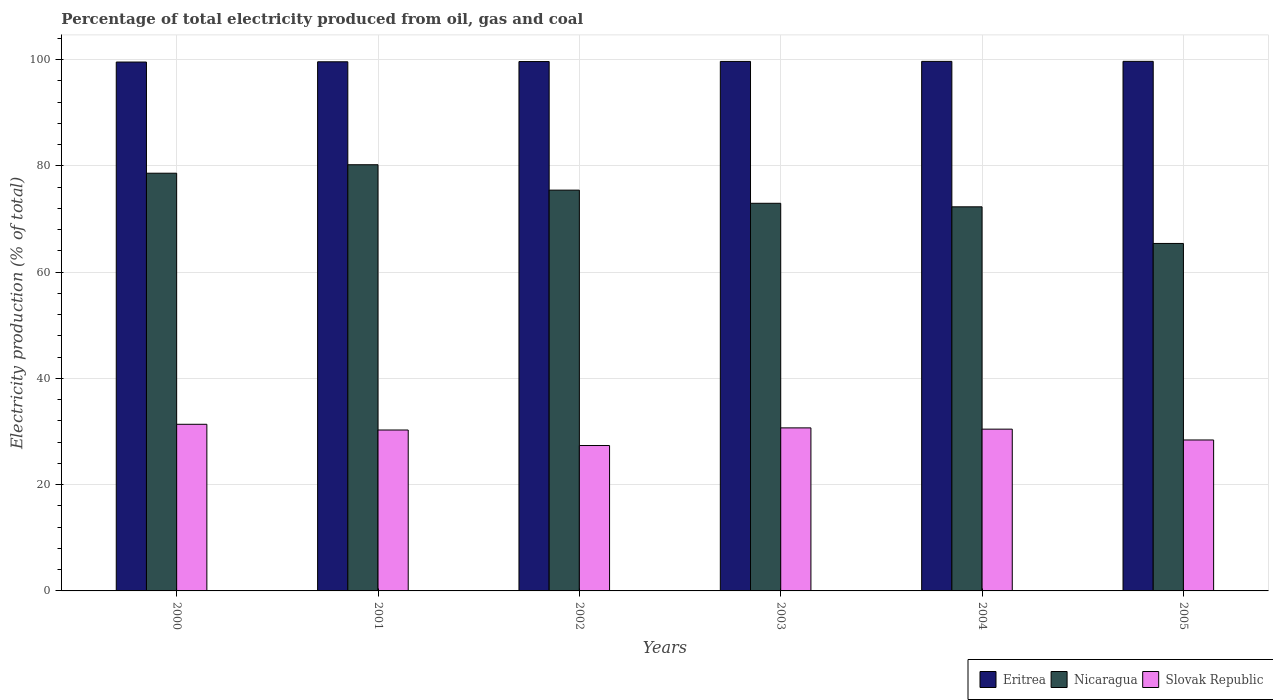How many different coloured bars are there?
Give a very brief answer. 3. How many groups of bars are there?
Offer a very short reply. 6. What is the label of the 5th group of bars from the left?
Give a very brief answer. 2004. In how many cases, is the number of bars for a given year not equal to the number of legend labels?
Give a very brief answer. 0. What is the electricity production in in Slovak Republic in 2003?
Your answer should be compact. 30.68. Across all years, what is the maximum electricity production in in Eritrea?
Offer a terse response. 99.65. Across all years, what is the minimum electricity production in in Eritrea?
Your answer should be very brief. 99.52. In which year was the electricity production in in Slovak Republic maximum?
Offer a terse response. 2000. What is the total electricity production in in Eritrea in the graph?
Your answer should be very brief. 597.65. What is the difference between the electricity production in in Eritrea in 2000 and that in 2005?
Ensure brevity in your answer.  -0.13. What is the difference between the electricity production in in Nicaragua in 2005 and the electricity production in in Slovak Republic in 2002?
Provide a succinct answer. 38.03. What is the average electricity production in in Slovak Republic per year?
Your answer should be compact. 29.75. In the year 2005, what is the difference between the electricity production in in Eritrea and electricity production in in Nicaragua?
Provide a succinct answer. 34.26. In how many years, is the electricity production in in Nicaragua greater than 4 %?
Provide a succinct answer. 6. What is the ratio of the electricity production in in Nicaragua in 2001 to that in 2003?
Ensure brevity in your answer.  1.1. What is the difference between the highest and the second highest electricity production in in Eritrea?
Provide a succinct answer. 0.01. What is the difference between the highest and the lowest electricity production in in Eritrea?
Offer a terse response. 0.13. In how many years, is the electricity production in in Nicaragua greater than the average electricity production in in Nicaragua taken over all years?
Ensure brevity in your answer.  3. What does the 3rd bar from the left in 2002 represents?
Make the answer very short. Slovak Republic. What does the 3rd bar from the right in 2004 represents?
Your answer should be compact. Eritrea. Are all the bars in the graph horizontal?
Offer a terse response. No. Where does the legend appear in the graph?
Give a very brief answer. Bottom right. What is the title of the graph?
Your response must be concise. Percentage of total electricity produced from oil, gas and coal. What is the label or title of the Y-axis?
Provide a succinct answer. Electricity production (% of total). What is the Electricity production (% of total) of Eritrea in 2000?
Give a very brief answer. 99.52. What is the Electricity production (% of total) in Nicaragua in 2000?
Offer a terse response. 78.6. What is the Electricity production (% of total) in Slovak Republic in 2000?
Keep it short and to the point. 31.36. What is the Electricity production (% of total) in Eritrea in 2001?
Provide a succinct answer. 99.57. What is the Electricity production (% of total) of Nicaragua in 2001?
Ensure brevity in your answer.  80.2. What is the Electricity production (% of total) in Slovak Republic in 2001?
Your answer should be compact. 30.28. What is the Electricity production (% of total) of Eritrea in 2002?
Your answer should be compact. 99.61. What is the Electricity production (% of total) of Nicaragua in 2002?
Your answer should be compact. 75.42. What is the Electricity production (% of total) of Slovak Republic in 2002?
Keep it short and to the point. 27.36. What is the Electricity production (% of total) of Eritrea in 2003?
Make the answer very short. 99.64. What is the Electricity production (% of total) of Nicaragua in 2003?
Offer a very short reply. 72.94. What is the Electricity production (% of total) in Slovak Republic in 2003?
Ensure brevity in your answer.  30.68. What is the Electricity production (% of total) of Eritrea in 2004?
Offer a very short reply. 99.65. What is the Electricity production (% of total) of Nicaragua in 2004?
Your answer should be compact. 72.28. What is the Electricity production (% of total) in Slovak Republic in 2004?
Provide a succinct answer. 30.44. What is the Electricity production (% of total) in Eritrea in 2005?
Your answer should be compact. 99.65. What is the Electricity production (% of total) in Nicaragua in 2005?
Keep it short and to the point. 65.39. What is the Electricity production (% of total) in Slovak Republic in 2005?
Your answer should be very brief. 28.4. Across all years, what is the maximum Electricity production (% of total) in Eritrea?
Keep it short and to the point. 99.65. Across all years, what is the maximum Electricity production (% of total) in Nicaragua?
Provide a succinct answer. 80.2. Across all years, what is the maximum Electricity production (% of total) of Slovak Republic?
Give a very brief answer. 31.36. Across all years, what is the minimum Electricity production (% of total) in Eritrea?
Ensure brevity in your answer.  99.52. Across all years, what is the minimum Electricity production (% of total) of Nicaragua?
Your answer should be compact. 65.39. Across all years, what is the minimum Electricity production (% of total) in Slovak Republic?
Provide a succinct answer. 27.36. What is the total Electricity production (% of total) in Eritrea in the graph?
Provide a succinct answer. 597.65. What is the total Electricity production (% of total) in Nicaragua in the graph?
Provide a succinct answer. 444.83. What is the total Electricity production (% of total) of Slovak Republic in the graph?
Your answer should be very brief. 178.52. What is the difference between the Electricity production (% of total) of Eritrea in 2000 and that in 2001?
Offer a terse response. -0.05. What is the difference between the Electricity production (% of total) of Nicaragua in 2000 and that in 2001?
Offer a very short reply. -1.59. What is the difference between the Electricity production (% of total) in Slovak Republic in 2000 and that in 2001?
Make the answer very short. 1.08. What is the difference between the Electricity production (% of total) in Eritrea in 2000 and that in 2002?
Offer a very short reply. -0.09. What is the difference between the Electricity production (% of total) of Nicaragua in 2000 and that in 2002?
Offer a very short reply. 3.19. What is the difference between the Electricity production (% of total) in Slovak Republic in 2000 and that in 2002?
Make the answer very short. 4. What is the difference between the Electricity production (% of total) of Eritrea in 2000 and that in 2003?
Your answer should be very brief. -0.12. What is the difference between the Electricity production (% of total) in Nicaragua in 2000 and that in 2003?
Offer a terse response. 5.66. What is the difference between the Electricity production (% of total) of Slovak Republic in 2000 and that in 2003?
Ensure brevity in your answer.  0.67. What is the difference between the Electricity production (% of total) of Eritrea in 2000 and that in 2004?
Give a very brief answer. -0.12. What is the difference between the Electricity production (% of total) in Nicaragua in 2000 and that in 2004?
Ensure brevity in your answer.  6.33. What is the difference between the Electricity production (% of total) of Slovak Republic in 2000 and that in 2004?
Provide a short and direct response. 0.91. What is the difference between the Electricity production (% of total) of Eritrea in 2000 and that in 2005?
Give a very brief answer. -0.13. What is the difference between the Electricity production (% of total) of Nicaragua in 2000 and that in 2005?
Ensure brevity in your answer.  13.22. What is the difference between the Electricity production (% of total) in Slovak Republic in 2000 and that in 2005?
Offer a very short reply. 2.95. What is the difference between the Electricity production (% of total) of Eritrea in 2001 and that in 2002?
Provide a short and direct response. -0.04. What is the difference between the Electricity production (% of total) of Nicaragua in 2001 and that in 2002?
Make the answer very short. 4.78. What is the difference between the Electricity production (% of total) of Slovak Republic in 2001 and that in 2002?
Your response must be concise. 2.92. What is the difference between the Electricity production (% of total) of Eritrea in 2001 and that in 2003?
Your answer should be very brief. -0.07. What is the difference between the Electricity production (% of total) in Nicaragua in 2001 and that in 2003?
Make the answer very short. 7.25. What is the difference between the Electricity production (% of total) in Slovak Republic in 2001 and that in 2003?
Provide a succinct answer. -0.4. What is the difference between the Electricity production (% of total) of Eritrea in 2001 and that in 2004?
Your response must be concise. -0.08. What is the difference between the Electricity production (% of total) in Nicaragua in 2001 and that in 2004?
Your response must be concise. 7.92. What is the difference between the Electricity production (% of total) of Slovak Republic in 2001 and that in 2004?
Keep it short and to the point. -0.16. What is the difference between the Electricity production (% of total) in Eritrea in 2001 and that in 2005?
Your response must be concise. -0.08. What is the difference between the Electricity production (% of total) in Nicaragua in 2001 and that in 2005?
Provide a succinct answer. 14.81. What is the difference between the Electricity production (% of total) in Slovak Republic in 2001 and that in 2005?
Provide a short and direct response. 1.88. What is the difference between the Electricity production (% of total) of Eritrea in 2002 and that in 2003?
Keep it short and to the point. -0.03. What is the difference between the Electricity production (% of total) of Nicaragua in 2002 and that in 2003?
Your response must be concise. 2.48. What is the difference between the Electricity production (% of total) in Slovak Republic in 2002 and that in 2003?
Offer a terse response. -3.32. What is the difference between the Electricity production (% of total) of Eritrea in 2002 and that in 2004?
Keep it short and to the point. -0.03. What is the difference between the Electricity production (% of total) of Nicaragua in 2002 and that in 2004?
Your answer should be very brief. 3.14. What is the difference between the Electricity production (% of total) of Slovak Republic in 2002 and that in 2004?
Ensure brevity in your answer.  -3.08. What is the difference between the Electricity production (% of total) of Eritrea in 2002 and that in 2005?
Ensure brevity in your answer.  -0.04. What is the difference between the Electricity production (% of total) of Nicaragua in 2002 and that in 2005?
Your answer should be very brief. 10.03. What is the difference between the Electricity production (% of total) in Slovak Republic in 2002 and that in 2005?
Ensure brevity in your answer.  -1.04. What is the difference between the Electricity production (% of total) in Eritrea in 2003 and that in 2004?
Make the answer very short. -0.01. What is the difference between the Electricity production (% of total) of Nicaragua in 2003 and that in 2004?
Your response must be concise. 0.66. What is the difference between the Electricity production (% of total) of Slovak Republic in 2003 and that in 2004?
Offer a terse response. 0.24. What is the difference between the Electricity production (% of total) in Eritrea in 2003 and that in 2005?
Provide a short and direct response. -0.01. What is the difference between the Electricity production (% of total) of Nicaragua in 2003 and that in 2005?
Make the answer very short. 7.56. What is the difference between the Electricity production (% of total) of Slovak Republic in 2003 and that in 2005?
Keep it short and to the point. 2.28. What is the difference between the Electricity production (% of total) of Eritrea in 2004 and that in 2005?
Your answer should be very brief. -0.01. What is the difference between the Electricity production (% of total) of Nicaragua in 2004 and that in 2005?
Make the answer very short. 6.89. What is the difference between the Electricity production (% of total) in Slovak Republic in 2004 and that in 2005?
Make the answer very short. 2.04. What is the difference between the Electricity production (% of total) of Eritrea in 2000 and the Electricity production (% of total) of Nicaragua in 2001?
Ensure brevity in your answer.  19.33. What is the difference between the Electricity production (% of total) of Eritrea in 2000 and the Electricity production (% of total) of Slovak Republic in 2001?
Your answer should be compact. 69.24. What is the difference between the Electricity production (% of total) in Nicaragua in 2000 and the Electricity production (% of total) in Slovak Republic in 2001?
Your answer should be compact. 48.32. What is the difference between the Electricity production (% of total) of Eritrea in 2000 and the Electricity production (% of total) of Nicaragua in 2002?
Provide a short and direct response. 24.1. What is the difference between the Electricity production (% of total) of Eritrea in 2000 and the Electricity production (% of total) of Slovak Republic in 2002?
Give a very brief answer. 72.16. What is the difference between the Electricity production (% of total) of Nicaragua in 2000 and the Electricity production (% of total) of Slovak Republic in 2002?
Your answer should be compact. 51.25. What is the difference between the Electricity production (% of total) of Eritrea in 2000 and the Electricity production (% of total) of Nicaragua in 2003?
Provide a short and direct response. 26.58. What is the difference between the Electricity production (% of total) in Eritrea in 2000 and the Electricity production (% of total) in Slovak Republic in 2003?
Offer a terse response. 68.84. What is the difference between the Electricity production (% of total) in Nicaragua in 2000 and the Electricity production (% of total) in Slovak Republic in 2003?
Offer a terse response. 47.92. What is the difference between the Electricity production (% of total) of Eritrea in 2000 and the Electricity production (% of total) of Nicaragua in 2004?
Your answer should be very brief. 27.24. What is the difference between the Electricity production (% of total) of Eritrea in 2000 and the Electricity production (% of total) of Slovak Republic in 2004?
Keep it short and to the point. 69.08. What is the difference between the Electricity production (% of total) in Nicaragua in 2000 and the Electricity production (% of total) in Slovak Republic in 2004?
Make the answer very short. 48.16. What is the difference between the Electricity production (% of total) in Eritrea in 2000 and the Electricity production (% of total) in Nicaragua in 2005?
Keep it short and to the point. 34.14. What is the difference between the Electricity production (% of total) of Eritrea in 2000 and the Electricity production (% of total) of Slovak Republic in 2005?
Your answer should be compact. 71.12. What is the difference between the Electricity production (% of total) in Nicaragua in 2000 and the Electricity production (% of total) in Slovak Republic in 2005?
Your response must be concise. 50.2. What is the difference between the Electricity production (% of total) in Eritrea in 2001 and the Electricity production (% of total) in Nicaragua in 2002?
Make the answer very short. 24.15. What is the difference between the Electricity production (% of total) in Eritrea in 2001 and the Electricity production (% of total) in Slovak Republic in 2002?
Your answer should be compact. 72.21. What is the difference between the Electricity production (% of total) of Nicaragua in 2001 and the Electricity production (% of total) of Slovak Republic in 2002?
Your response must be concise. 52.84. What is the difference between the Electricity production (% of total) in Eritrea in 2001 and the Electricity production (% of total) in Nicaragua in 2003?
Your answer should be very brief. 26.63. What is the difference between the Electricity production (% of total) in Eritrea in 2001 and the Electricity production (% of total) in Slovak Republic in 2003?
Provide a short and direct response. 68.89. What is the difference between the Electricity production (% of total) in Nicaragua in 2001 and the Electricity production (% of total) in Slovak Republic in 2003?
Provide a short and direct response. 49.52. What is the difference between the Electricity production (% of total) of Eritrea in 2001 and the Electricity production (% of total) of Nicaragua in 2004?
Your answer should be very brief. 27.29. What is the difference between the Electricity production (% of total) of Eritrea in 2001 and the Electricity production (% of total) of Slovak Republic in 2004?
Provide a succinct answer. 69.13. What is the difference between the Electricity production (% of total) in Nicaragua in 2001 and the Electricity production (% of total) in Slovak Republic in 2004?
Ensure brevity in your answer.  49.76. What is the difference between the Electricity production (% of total) in Eritrea in 2001 and the Electricity production (% of total) in Nicaragua in 2005?
Your response must be concise. 34.18. What is the difference between the Electricity production (% of total) in Eritrea in 2001 and the Electricity production (% of total) in Slovak Republic in 2005?
Your answer should be very brief. 71.17. What is the difference between the Electricity production (% of total) in Nicaragua in 2001 and the Electricity production (% of total) in Slovak Republic in 2005?
Provide a succinct answer. 51.8. What is the difference between the Electricity production (% of total) of Eritrea in 2002 and the Electricity production (% of total) of Nicaragua in 2003?
Your answer should be very brief. 26.67. What is the difference between the Electricity production (% of total) of Eritrea in 2002 and the Electricity production (% of total) of Slovak Republic in 2003?
Give a very brief answer. 68.93. What is the difference between the Electricity production (% of total) of Nicaragua in 2002 and the Electricity production (% of total) of Slovak Republic in 2003?
Keep it short and to the point. 44.74. What is the difference between the Electricity production (% of total) of Eritrea in 2002 and the Electricity production (% of total) of Nicaragua in 2004?
Your answer should be compact. 27.33. What is the difference between the Electricity production (% of total) in Eritrea in 2002 and the Electricity production (% of total) in Slovak Republic in 2004?
Provide a succinct answer. 69.17. What is the difference between the Electricity production (% of total) of Nicaragua in 2002 and the Electricity production (% of total) of Slovak Republic in 2004?
Give a very brief answer. 44.98. What is the difference between the Electricity production (% of total) in Eritrea in 2002 and the Electricity production (% of total) in Nicaragua in 2005?
Offer a terse response. 34.23. What is the difference between the Electricity production (% of total) in Eritrea in 2002 and the Electricity production (% of total) in Slovak Republic in 2005?
Your response must be concise. 71.21. What is the difference between the Electricity production (% of total) of Nicaragua in 2002 and the Electricity production (% of total) of Slovak Republic in 2005?
Make the answer very short. 47.02. What is the difference between the Electricity production (% of total) of Eritrea in 2003 and the Electricity production (% of total) of Nicaragua in 2004?
Your answer should be compact. 27.36. What is the difference between the Electricity production (% of total) in Eritrea in 2003 and the Electricity production (% of total) in Slovak Republic in 2004?
Give a very brief answer. 69.2. What is the difference between the Electricity production (% of total) in Nicaragua in 2003 and the Electricity production (% of total) in Slovak Republic in 2004?
Your answer should be compact. 42.5. What is the difference between the Electricity production (% of total) in Eritrea in 2003 and the Electricity production (% of total) in Nicaragua in 2005?
Offer a terse response. 34.25. What is the difference between the Electricity production (% of total) of Eritrea in 2003 and the Electricity production (% of total) of Slovak Republic in 2005?
Your answer should be very brief. 71.24. What is the difference between the Electricity production (% of total) of Nicaragua in 2003 and the Electricity production (% of total) of Slovak Republic in 2005?
Give a very brief answer. 44.54. What is the difference between the Electricity production (% of total) in Eritrea in 2004 and the Electricity production (% of total) in Nicaragua in 2005?
Keep it short and to the point. 34.26. What is the difference between the Electricity production (% of total) of Eritrea in 2004 and the Electricity production (% of total) of Slovak Republic in 2005?
Offer a very short reply. 71.24. What is the difference between the Electricity production (% of total) in Nicaragua in 2004 and the Electricity production (% of total) in Slovak Republic in 2005?
Give a very brief answer. 43.88. What is the average Electricity production (% of total) of Eritrea per year?
Offer a very short reply. 99.61. What is the average Electricity production (% of total) in Nicaragua per year?
Your response must be concise. 74.14. What is the average Electricity production (% of total) of Slovak Republic per year?
Provide a succinct answer. 29.75. In the year 2000, what is the difference between the Electricity production (% of total) of Eritrea and Electricity production (% of total) of Nicaragua?
Make the answer very short. 20.92. In the year 2000, what is the difference between the Electricity production (% of total) in Eritrea and Electricity production (% of total) in Slovak Republic?
Make the answer very short. 68.17. In the year 2000, what is the difference between the Electricity production (% of total) in Nicaragua and Electricity production (% of total) in Slovak Republic?
Ensure brevity in your answer.  47.25. In the year 2001, what is the difference between the Electricity production (% of total) of Eritrea and Electricity production (% of total) of Nicaragua?
Make the answer very short. 19.37. In the year 2001, what is the difference between the Electricity production (% of total) in Eritrea and Electricity production (% of total) in Slovak Republic?
Keep it short and to the point. 69.29. In the year 2001, what is the difference between the Electricity production (% of total) of Nicaragua and Electricity production (% of total) of Slovak Republic?
Give a very brief answer. 49.92. In the year 2002, what is the difference between the Electricity production (% of total) of Eritrea and Electricity production (% of total) of Nicaragua?
Give a very brief answer. 24.19. In the year 2002, what is the difference between the Electricity production (% of total) in Eritrea and Electricity production (% of total) in Slovak Republic?
Your answer should be very brief. 72.25. In the year 2002, what is the difference between the Electricity production (% of total) in Nicaragua and Electricity production (% of total) in Slovak Republic?
Provide a short and direct response. 48.06. In the year 2003, what is the difference between the Electricity production (% of total) in Eritrea and Electricity production (% of total) in Nicaragua?
Provide a succinct answer. 26.7. In the year 2003, what is the difference between the Electricity production (% of total) in Eritrea and Electricity production (% of total) in Slovak Republic?
Keep it short and to the point. 68.96. In the year 2003, what is the difference between the Electricity production (% of total) of Nicaragua and Electricity production (% of total) of Slovak Republic?
Give a very brief answer. 42.26. In the year 2004, what is the difference between the Electricity production (% of total) of Eritrea and Electricity production (% of total) of Nicaragua?
Keep it short and to the point. 27.37. In the year 2004, what is the difference between the Electricity production (% of total) in Eritrea and Electricity production (% of total) in Slovak Republic?
Your answer should be compact. 69.2. In the year 2004, what is the difference between the Electricity production (% of total) of Nicaragua and Electricity production (% of total) of Slovak Republic?
Ensure brevity in your answer.  41.84. In the year 2005, what is the difference between the Electricity production (% of total) in Eritrea and Electricity production (% of total) in Nicaragua?
Make the answer very short. 34.26. In the year 2005, what is the difference between the Electricity production (% of total) in Eritrea and Electricity production (% of total) in Slovak Republic?
Provide a short and direct response. 71.25. In the year 2005, what is the difference between the Electricity production (% of total) in Nicaragua and Electricity production (% of total) in Slovak Republic?
Ensure brevity in your answer.  36.99. What is the ratio of the Electricity production (% of total) in Nicaragua in 2000 to that in 2001?
Make the answer very short. 0.98. What is the ratio of the Electricity production (% of total) in Slovak Republic in 2000 to that in 2001?
Your response must be concise. 1.04. What is the ratio of the Electricity production (% of total) in Nicaragua in 2000 to that in 2002?
Your answer should be very brief. 1.04. What is the ratio of the Electricity production (% of total) in Slovak Republic in 2000 to that in 2002?
Offer a terse response. 1.15. What is the ratio of the Electricity production (% of total) of Nicaragua in 2000 to that in 2003?
Offer a very short reply. 1.08. What is the ratio of the Electricity production (% of total) in Eritrea in 2000 to that in 2004?
Offer a very short reply. 1. What is the ratio of the Electricity production (% of total) of Nicaragua in 2000 to that in 2004?
Make the answer very short. 1.09. What is the ratio of the Electricity production (% of total) of Slovak Republic in 2000 to that in 2004?
Offer a terse response. 1.03. What is the ratio of the Electricity production (% of total) of Eritrea in 2000 to that in 2005?
Your answer should be very brief. 1. What is the ratio of the Electricity production (% of total) of Nicaragua in 2000 to that in 2005?
Provide a succinct answer. 1.2. What is the ratio of the Electricity production (% of total) in Slovak Republic in 2000 to that in 2005?
Offer a terse response. 1.1. What is the ratio of the Electricity production (% of total) of Eritrea in 2001 to that in 2002?
Ensure brevity in your answer.  1. What is the ratio of the Electricity production (% of total) in Nicaragua in 2001 to that in 2002?
Ensure brevity in your answer.  1.06. What is the ratio of the Electricity production (% of total) in Slovak Republic in 2001 to that in 2002?
Your response must be concise. 1.11. What is the ratio of the Electricity production (% of total) in Nicaragua in 2001 to that in 2003?
Offer a very short reply. 1.1. What is the ratio of the Electricity production (% of total) in Slovak Republic in 2001 to that in 2003?
Offer a very short reply. 0.99. What is the ratio of the Electricity production (% of total) in Nicaragua in 2001 to that in 2004?
Keep it short and to the point. 1.11. What is the ratio of the Electricity production (% of total) in Nicaragua in 2001 to that in 2005?
Your answer should be very brief. 1.23. What is the ratio of the Electricity production (% of total) in Slovak Republic in 2001 to that in 2005?
Make the answer very short. 1.07. What is the ratio of the Electricity production (% of total) in Eritrea in 2002 to that in 2003?
Make the answer very short. 1. What is the ratio of the Electricity production (% of total) of Nicaragua in 2002 to that in 2003?
Provide a short and direct response. 1.03. What is the ratio of the Electricity production (% of total) in Slovak Republic in 2002 to that in 2003?
Provide a short and direct response. 0.89. What is the ratio of the Electricity production (% of total) in Eritrea in 2002 to that in 2004?
Your response must be concise. 1. What is the ratio of the Electricity production (% of total) in Nicaragua in 2002 to that in 2004?
Ensure brevity in your answer.  1.04. What is the ratio of the Electricity production (% of total) of Slovak Republic in 2002 to that in 2004?
Your answer should be very brief. 0.9. What is the ratio of the Electricity production (% of total) of Nicaragua in 2002 to that in 2005?
Keep it short and to the point. 1.15. What is the ratio of the Electricity production (% of total) in Slovak Republic in 2002 to that in 2005?
Provide a succinct answer. 0.96. What is the ratio of the Electricity production (% of total) of Eritrea in 2003 to that in 2004?
Keep it short and to the point. 1. What is the ratio of the Electricity production (% of total) in Nicaragua in 2003 to that in 2004?
Your answer should be very brief. 1.01. What is the ratio of the Electricity production (% of total) of Slovak Republic in 2003 to that in 2004?
Offer a terse response. 1.01. What is the ratio of the Electricity production (% of total) of Nicaragua in 2003 to that in 2005?
Give a very brief answer. 1.12. What is the ratio of the Electricity production (% of total) of Slovak Republic in 2003 to that in 2005?
Offer a terse response. 1.08. What is the ratio of the Electricity production (% of total) in Eritrea in 2004 to that in 2005?
Provide a short and direct response. 1. What is the ratio of the Electricity production (% of total) of Nicaragua in 2004 to that in 2005?
Offer a very short reply. 1.11. What is the ratio of the Electricity production (% of total) of Slovak Republic in 2004 to that in 2005?
Your response must be concise. 1.07. What is the difference between the highest and the second highest Electricity production (% of total) in Eritrea?
Provide a short and direct response. 0.01. What is the difference between the highest and the second highest Electricity production (% of total) of Nicaragua?
Your answer should be very brief. 1.59. What is the difference between the highest and the second highest Electricity production (% of total) in Slovak Republic?
Offer a terse response. 0.67. What is the difference between the highest and the lowest Electricity production (% of total) of Eritrea?
Make the answer very short. 0.13. What is the difference between the highest and the lowest Electricity production (% of total) of Nicaragua?
Keep it short and to the point. 14.81. What is the difference between the highest and the lowest Electricity production (% of total) of Slovak Republic?
Offer a terse response. 4. 